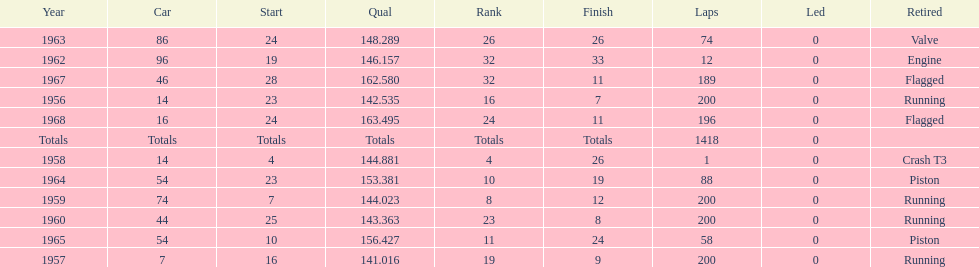How many times did he finish all 200 laps? 4. Can you give me this table as a dict? {'header': ['Year', 'Car', 'Start', 'Qual', 'Rank', 'Finish', 'Laps', 'Led', 'Retired'], 'rows': [['1963', '86', '24', '148.289', '26', '26', '74', '0', 'Valve'], ['1962', '96', '19', '146.157', '32', '33', '12', '0', 'Engine'], ['1967', '46', '28', '162.580', '32', '11', '189', '0', 'Flagged'], ['1956', '14', '23', '142.535', '16', '7', '200', '0', 'Running'], ['1968', '16', '24', '163.495', '24', '11', '196', '0', 'Flagged'], ['Totals', 'Totals', 'Totals', 'Totals', 'Totals', 'Totals', '1418', '0', ''], ['1958', '14', '4', '144.881', '4', '26', '1', '0', 'Crash T3'], ['1964', '54', '23', '153.381', '10', '19', '88', '0', 'Piston'], ['1959', '74', '7', '144.023', '8', '12', '200', '0', 'Running'], ['1960', '44', '25', '143.363', '23', '8', '200', '0', 'Running'], ['1965', '54', '10', '156.427', '11', '24', '58', '0', 'Piston'], ['1957', '7', '16', '141.016', '19', '9', '200', '0', 'Running']]} 